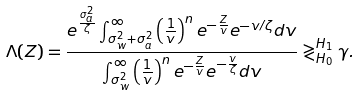<formula> <loc_0><loc_0><loc_500><loc_500>\Lambda ( Z ) & = \frac { e ^ { \frac { \sigma _ { a } ^ { 2 } } { \zeta } } \int _ { \sigma _ { w } ^ { 2 } + \sigma _ { a } ^ { 2 } } ^ { \infty } \left ( \frac { 1 } { v } \right ) ^ { n } e ^ { - \frac { Z } { v } } e ^ { - v / \zeta } d v } { \int _ { \sigma _ { w } ^ { 2 } } ^ { \infty } \left ( \frac { 1 } { v } \right ) ^ { n } e ^ { - \frac { Z } { v } } e ^ { - \frac { v } { \zeta } } d v } \gtrless _ { H _ { 0 } } ^ { H _ { 1 } } \gamma .</formula> 